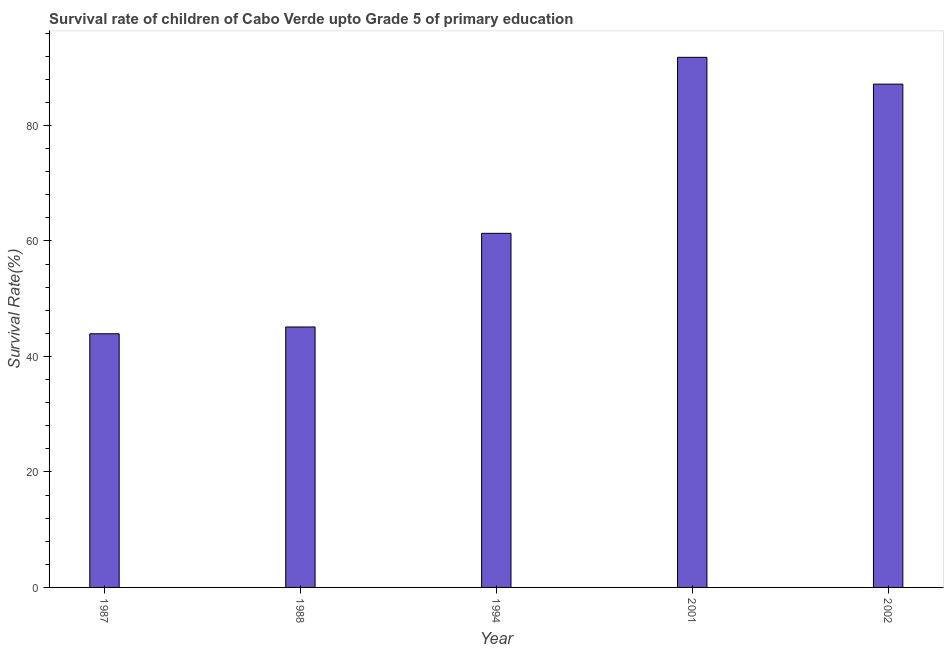Does the graph contain any zero values?
Offer a very short reply. No. What is the title of the graph?
Offer a terse response. Survival rate of children of Cabo Verde upto Grade 5 of primary education. What is the label or title of the X-axis?
Make the answer very short. Year. What is the label or title of the Y-axis?
Offer a very short reply. Survival Rate(%). What is the survival rate in 1988?
Offer a very short reply. 45.1. Across all years, what is the maximum survival rate?
Your answer should be compact. 91.79. Across all years, what is the minimum survival rate?
Keep it short and to the point. 43.93. What is the sum of the survival rate?
Your answer should be very brief. 329.29. What is the difference between the survival rate in 1987 and 1994?
Give a very brief answer. -17.39. What is the average survival rate per year?
Give a very brief answer. 65.86. What is the median survival rate?
Give a very brief answer. 61.32. Do a majority of the years between 1987 and 1994 (inclusive) have survival rate greater than 48 %?
Offer a very short reply. No. What is the ratio of the survival rate in 1987 to that in 1994?
Ensure brevity in your answer.  0.72. Is the survival rate in 1988 less than that in 1994?
Your answer should be compact. Yes. Is the difference between the survival rate in 1987 and 2001 greater than the difference between any two years?
Your answer should be very brief. Yes. What is the difference between the highest and the second highest survival rate?
Your response must be concise. 4.64. What is the difference between the highest and the lowest survival rate?
Give a very brief answer. 47.87. In how many years, is the survival rate greater than the average survival rate taken over all years?
Provide a succinct answer. 2. Are the values on the major ticks of Y-axis written in scientific E-notation?
Give a very brief answer. No. What is the Survival Rate(%) of 1987?
Your answer should be compact. 43.93. What is the Survival Rate(%) of 1988?
Ensure brevity in your answer.  45.1. What is the Survival Rate(%) in 1994?
Provide a short and direct response. 61.32. What is the Survival Rate(%) of 2001?
Your answer should be very brief. 91.79. What is the Survival Rate(%) of 2002?
Provide a succinct answer. 87.15. What is the difference between the Survival Rate(%) in 1987 and 1988?
Give a very brief answer. -1.18. What is the difference between the Survival Rate(%) in 1987 and 1994?
Your answer should be very brief. -17.39. What is the difference between the Survival Rate(%) in 1987 and 2001?
Provide a succinct answer. -47.87. What is the difference between the Survival Rate(%) in 1987 and 2002?
Your response must be concise. -43.23. What is the difference between the Survival Rate(%) in 1988 and 1994?
Your answer should be very brief. -16.21. What is the difference between the Survival Rate(%) in 1988 and 2001?
Your answer should be very brief. -46.69. What is the difference between the Survival Rate(%) in 1988 and 2002?
Your answer should be very brief. -42.05. What is the difference between the Survival Rate(%) in 1994 and 2001?
Ensure brevity in your answer.  -30.48. What is the difference between the Survival Rate(%) in 1994 and 2002?
Offer a terse response. -25.84. What is the difference between the Survival Rate(%) in 2001 and 2002?
Make the answer very short. 4.64. What is the ratio of the Survival Rate(%) in 1987 to that in 1994?
Your answer should be compact. 0.72. What is the ratio of the Survival Rate(%) in 1987 to that in 2001?
Offer a terse response. 0.48. What is the ratio of the Survival Rate(%) in 1987 to that in 2002?
Offer a terse response. 0.5. What is the ratio of the Survival Rate(%) in 1988 to that in 1994?
Give a very brief answer. 0.74. What is the ratio of the Survival Rate(%) in 1988 to that in 2001?
Offer a very short reply. 0.49. What is the ratio of the Survival Rate(%) in 1988 to that in 2002?
Keep it short and to the point. 0.52. What is the ratio of the Survival Rate(%) in 1994 to that in 2001?
Provide a succinct answer. 0.67. What is the ratio of the Survival Rate(%) in 1994 to that in 2002?
Keep it short and to the point. 0.7. What is the ratio of the Survival Rate(%) in 2001 to that in 2002?
Provide a succinct answer. 1.05. 